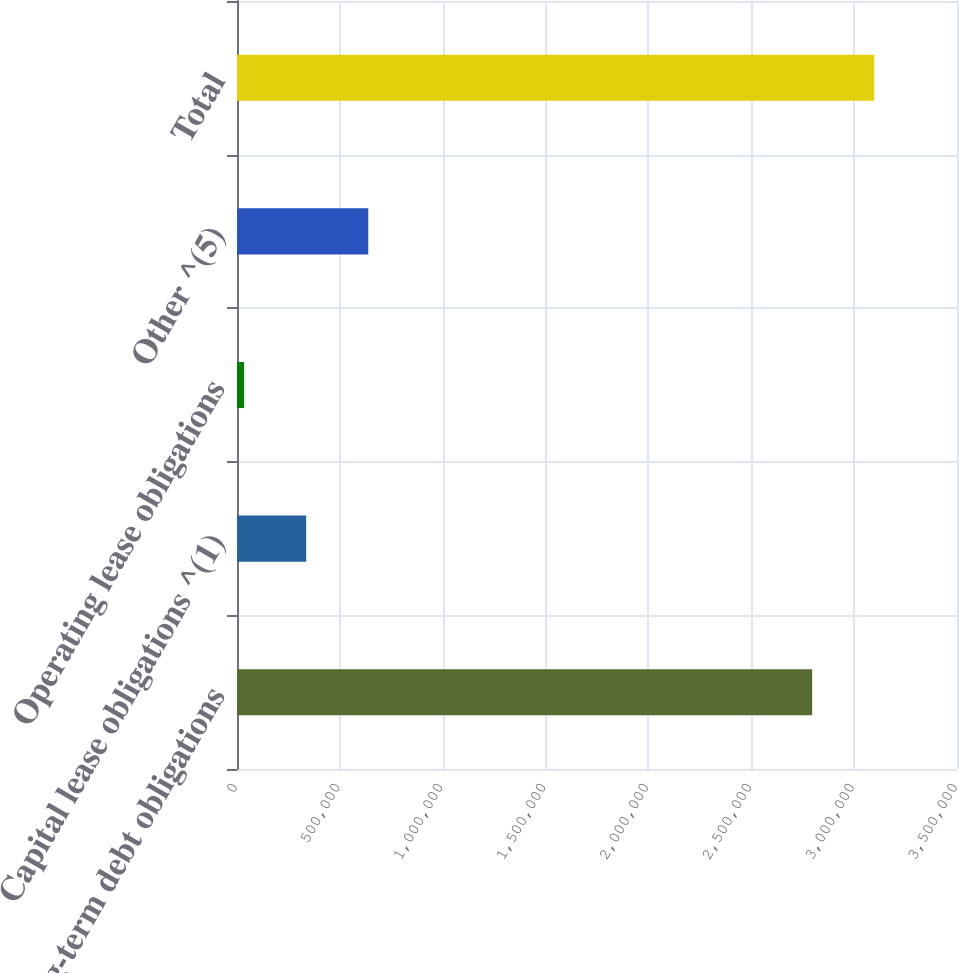<chart> <loc_0><loc_0><loc_500><loc_500><bar_chart><fcel>Long-term debt obligations<fcel>Capital lease obligations ^(1)<fcel>Operating lease obligations<fcel>Other ^(5)<fcel>Total<nl><fcel>2.79583e+06<fcel>336220<fcel>34356<fcel>638084<fcel>3.09769e+06<nl></chart> 